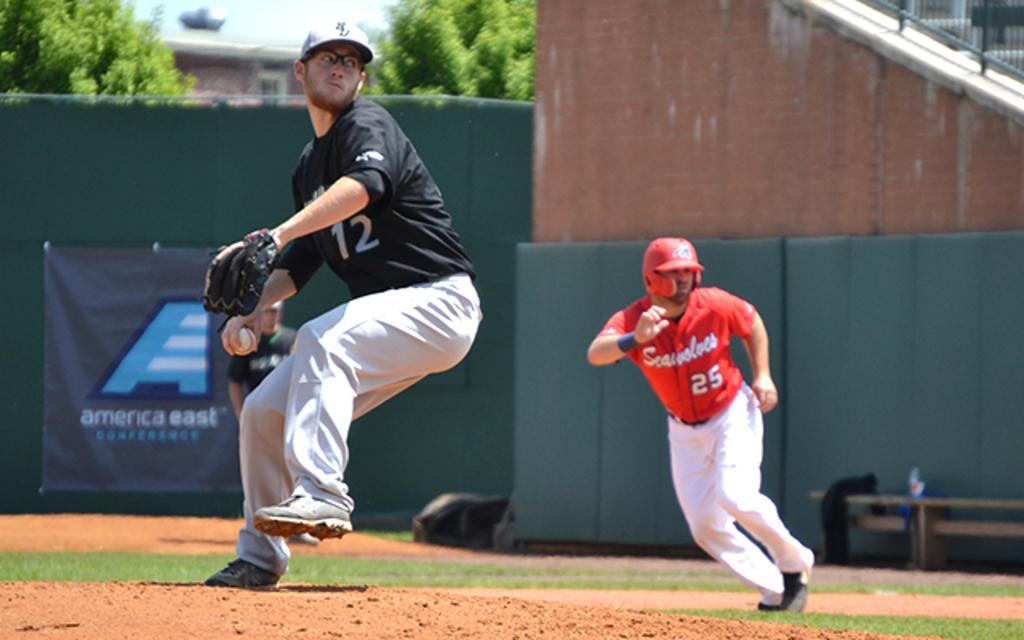Describe this image in one or two sentences. In the picture we can see people playing baseball. In the foreground we can see a person throwing ball and there is soil also. In the middle towards right there is a person running. In the background there are trees, banner, board, buildings and sky. 